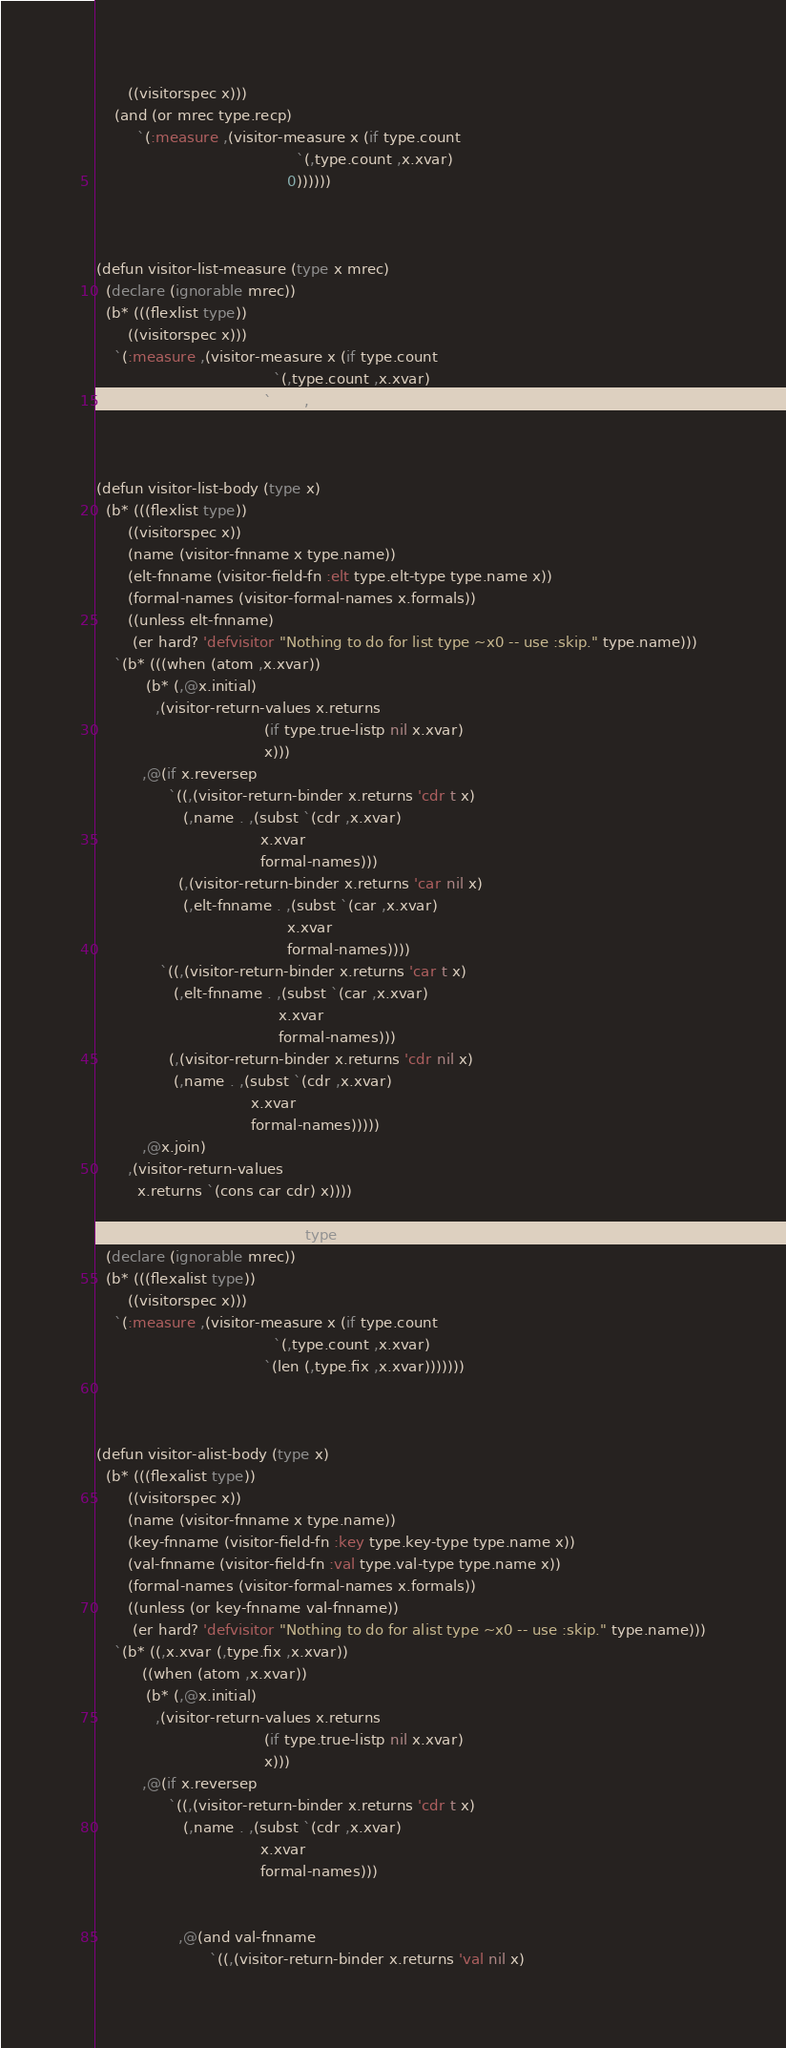Convert code to text. <code><loc_0><loc_0><loc_500><loc_500><_Lisp_>       ((visitorspec x)))
    (and (or mrec type.recp)
         `(:measure ,(visitor-measure x (if type.count
                                            `(,type.count ,x.xvar)
                                          0))))))
                        


(defun visitor-list-measure (type x mrec)
  (declare (ignorable mrec))
  (b* (((flexlist type))
       ((visitorspec x)))
    `(:measure ,(visitor-measure x (if type.count
                                       `(,type.count ,x.xvar)
                                     `(len ,x.xvar))))))
  


(defun visitor-list-body (type x)
  (b* (((flexlist type))
       ((visitorspec x))
       (name (visitor-fnname x type.name))
       (elt-fnname (visitor-field-fn :elt type.elt-type type.name x))
       (formal-names (visitor-formal-names x.formals))
       ((unless elt-fnname)
        (er hard? 'defvisitor "Nothing to do for list type ~x0 -- use :skip." type.name)))
    `(b* (((when (atom ,x.xvar))
           (b* (,@x.initial)
             ,(visitor-return-values x.returns
                                     (if type.true-listp nil x.xvar)
                                     x)))
          ,@(if x.reversep
                `((,(visitor-return-binder x.returns 'cdr t x)
                   (,name . ,(subst `(cdr ,x.xvar)
                                    x.xvar
                                    formal-names)))
                  (,(visitor-return-binder x.returns 'car nil x)
                   (,elt-fnname . ,(subst `(car ,x.xvar)
                                          x.xvar
                                          formal-names))))
              `((,(visitor-return-binder x.returns 'car t x)
                 (,elt-fnname . ,(subst `(car ,x.xvar)
                                        x.xvar
                                        formal-names)))
                (,(visitor-return-binder x.returns 'cdr nil x)
                 (,name . ,(subst `(cdr ,x.xvar)
                                  x.xvar
                                  formal-names)))))
          ,@x.join)
       ,(visitor-return-values
         x.returns `(cons car cdr) x))))

(defun visitor-alist-measure (type x mrec)
  (declare (ignorable mrec))
  (b* (((flexalist type))
       ((visitorspec x)))
    `(:measure ,(visitor-measure x (if type.count
                                       `(,type.count ,x.xvar)
                                     `(len (,type.fix ,x.xvar)))))))



(defun visitor-alist-body (type x)
  (b* (((flexalist type))
       ((visitorspec x))
       (name (visitor-fnname x type.name))
       (key-fnname (visitor-field-fn :key type.key-type type.name x))
       (val-fnname (visitor-field-fn :val type.val-type type.name x))
       (formal-names (visitor-formal-names x.formals))
       ((unless (or key-fnname val-fnname))
        (er hard? 'defvisitor "Nothing to do for alist type ~x0 -- use :skip." type.name)))
    `(b* ((,x.xvar (,type.fix ,x.xvar))
          ((when (atom ,x.xvar))
           (b* (,@x.initial)
             ,(visitor-return-values x.returns
                                     (if type.true-listp nil x.xvar)
                                     x)))
          ,@(if x.reversep
                `((,(visitor-return-binder x.returns 'cdr t x)
                   (,name . ,(subst `(cdr ,x.xvar)
                                    x.xvar
                                    formal-names)))
                  
                  
                  ,@(and val-fnname
                         `((,(visitor-return-binder x.returns 'val nil x)</code> 